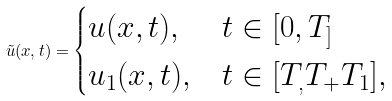Convert formula to latex. <formula><loc_0><loc_0><loc_500><loc_500>\tilde { u } ( x , t ) = \begin{cases} u ( x , t ) , & t \in [ 0 , T _ { ] } \\ u _ { 1 } ( x , t ) , & t \in [ T _ { , } T _ { + } T _ { 1 } ] , \end{cases}</formula> 